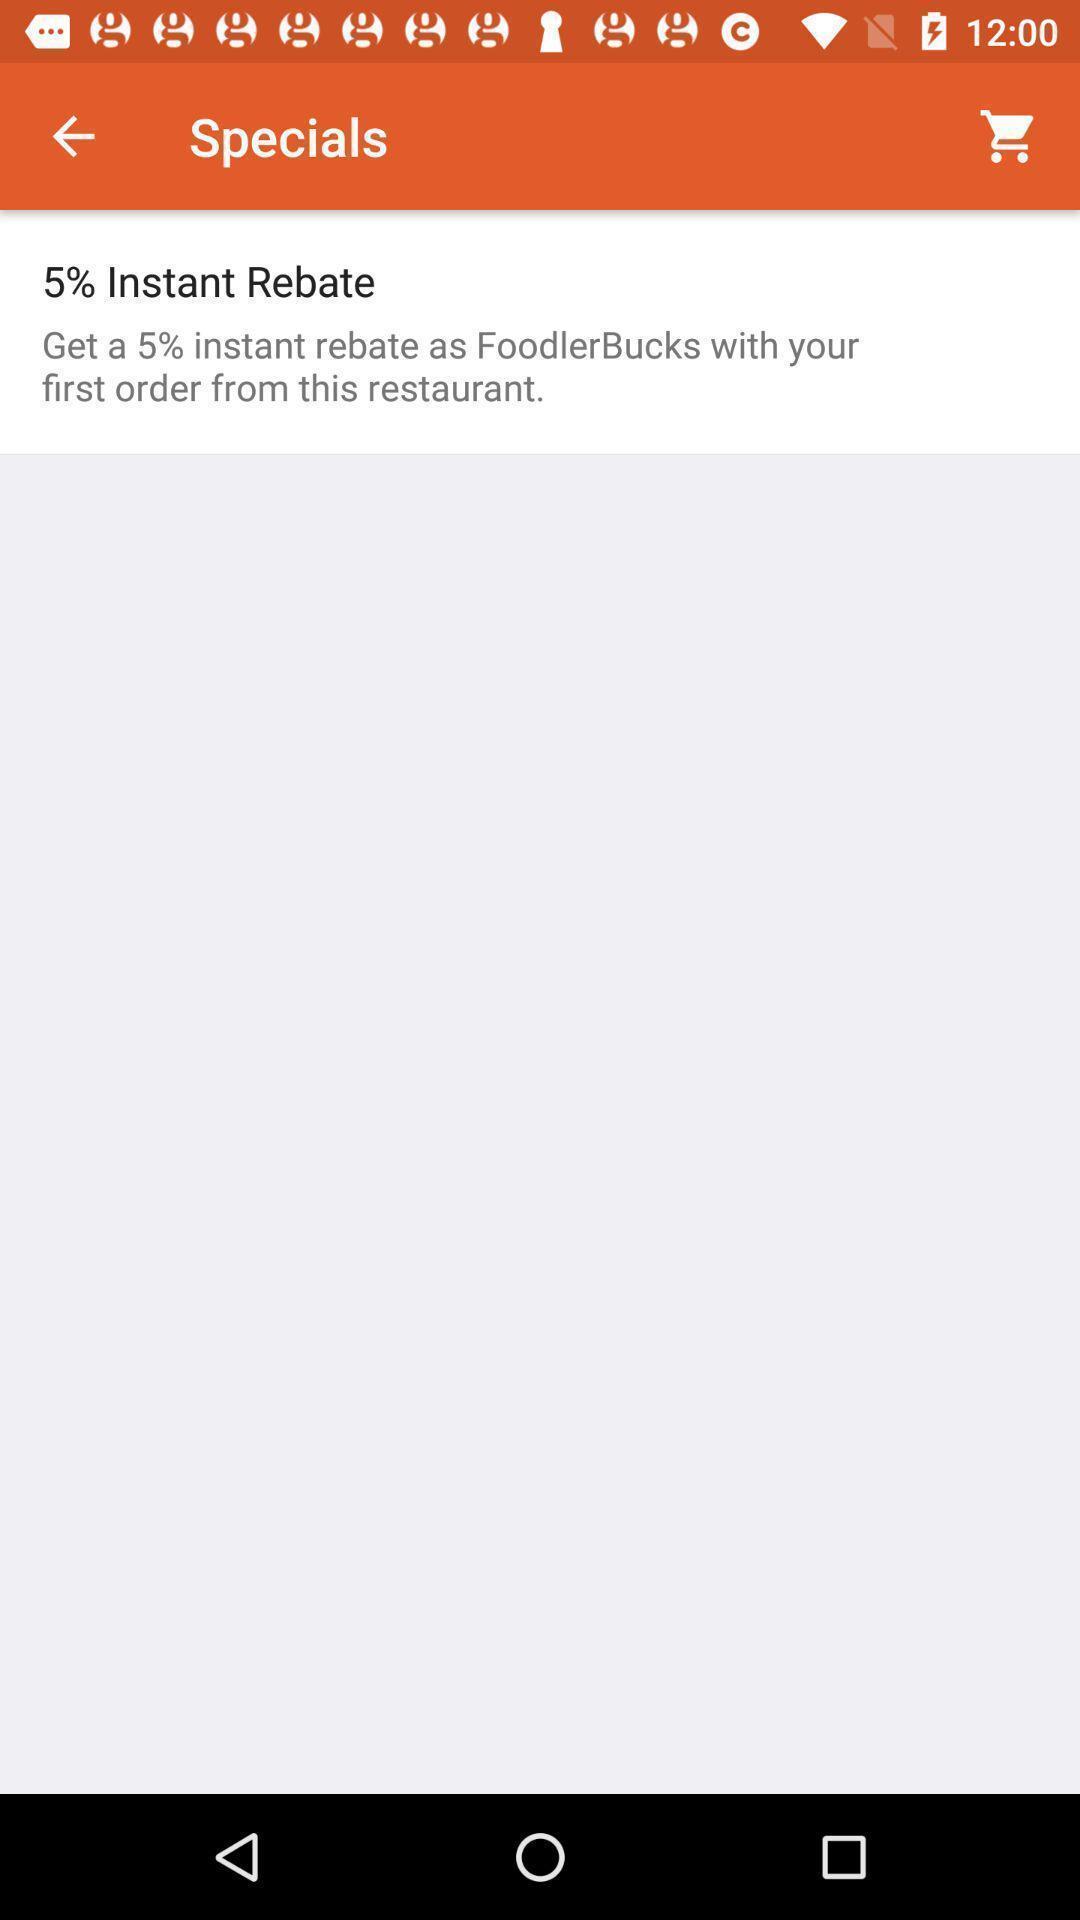Tell me about the visual elements in this screen capture. Screen displaying the page of food app. 